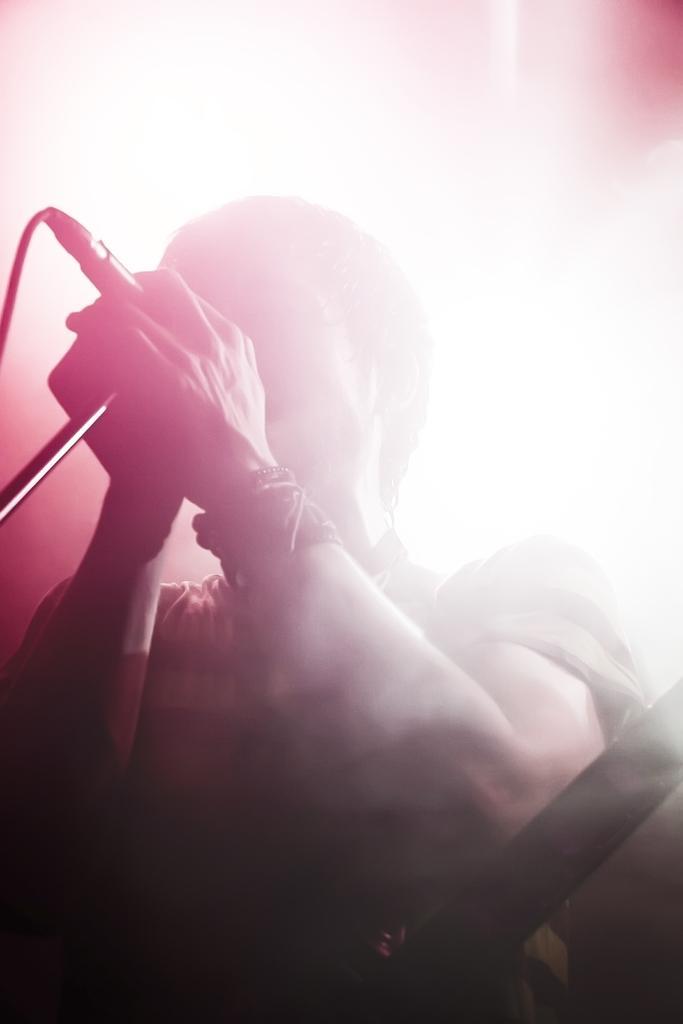Please provide a concise description of this image. In the image there is a person holding a mic and singing and in the background there is bright light. 